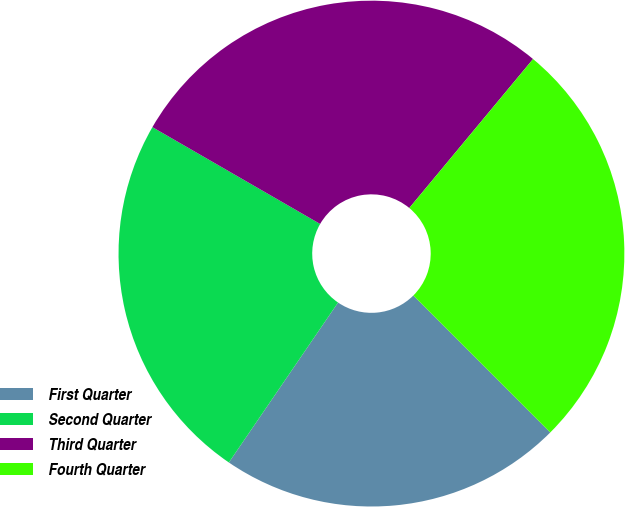Convert chart to OTSL. <chart><loc_0><loc_0><loc_500><loc_500><pie_chart><fcel>First Quarter<fcel>Second Quarter<fcel>Third Quarter<fcel>Fourth Quarter<nl><fcel>22.03%<fcel>23.8%<fcel>27.7%<fcel>26.47%<nl></chart> 